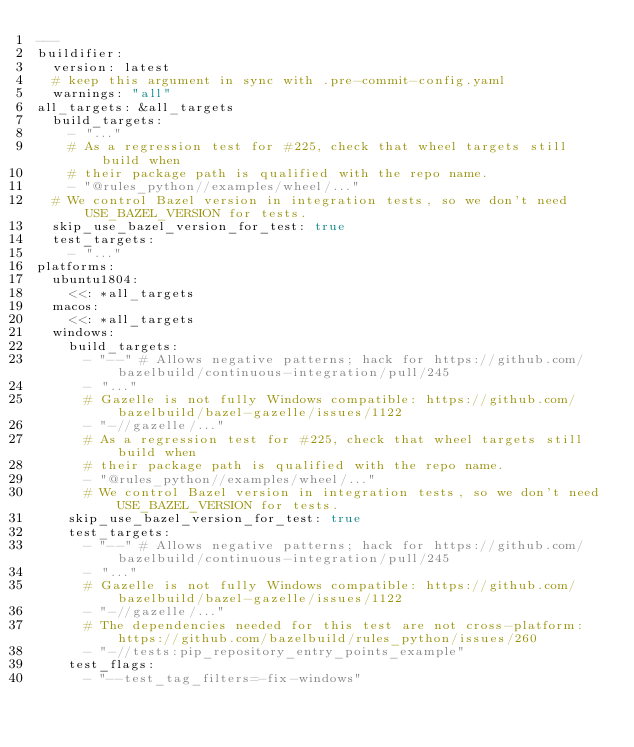Convert code to text. <code><loc_0><loc_0><loc_500><loc_500><_YAML_>---
buildifier:
  version: latest
  # keep this argument in sync with .pre-commit-config.yaml
  warnings: "all"
all_targets: &all_targets
  build_targets:
    - "..."
    # As a regression test for #225, check that wheel targets still build when
    # their package path is qualified with the repo name.
    - "@rules_python//examples/wheel/..."
  # We control Bazel version in integration tests, so we don't need USE_BAZEL_VERSION for tests.
  skip_use_bazel_version_for_test: true
  test_targets:
    - "..."
platforms:
  ubuntu1804:
    <<: *all_targets
  macos:
    <<: *all_targets
  windows:
    build_targets:
      - "--" # Allows negative patterns; hack for https://github.com/bazelbuild/continuous-integration/pull/245
      - "..."
      # Gazelle is not fully Windows compatible: https://github.com/bazelbuild/bazel-gazelle/issues/1122
      - "-//gazelle/..."
      # As a regression test for #225, check that wheel targets still build when
      # their package path is qualified with the repo name.
      - "@rules_python//examples/wheel/..."
      # We control Bazel version in integration tests, so we don't need USE_BAZEL_VERSION for tests.
    skip_use_bazel_version_for_test: true
    test_targets:
      - "--" # Allows negative patterns; hack for https://github.com/bazelbuild/continuous-integration/pull/245
      - "..."
      # Gazelle is not fully Windows compatible: https://github.com/bazelbuild/bazel-gazelle/issues/1122
      - "-//gazelle/..."
      # The dependencies needed for this test are not cross-platform: https://github.com/bazelbuild/rules_python/issues/260
      - "-//tests:pip_repository_entry_points_example"
    test_flags:
      - "--test_tag_filters=-fix-windows"</code> 